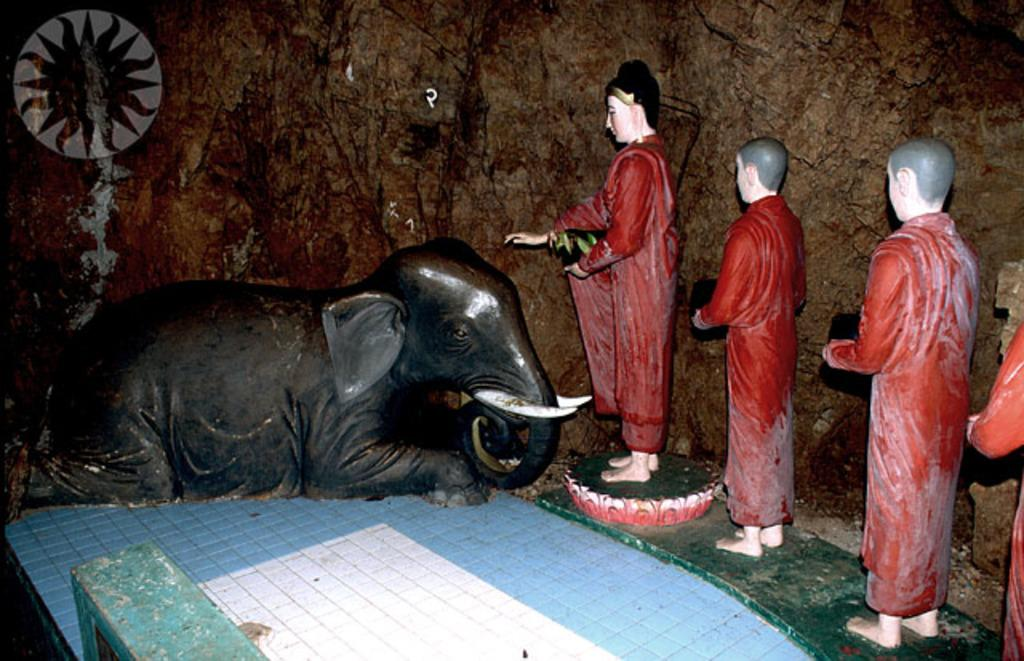What type of statue is present in the image? There is an elephant statue in the image. Are there any other statues in the image besides the elephant? Yes, there are other statues in the image. How many tomatoes are on the tiger's back in the image? There is no tiger or tomatoes present in the image. 